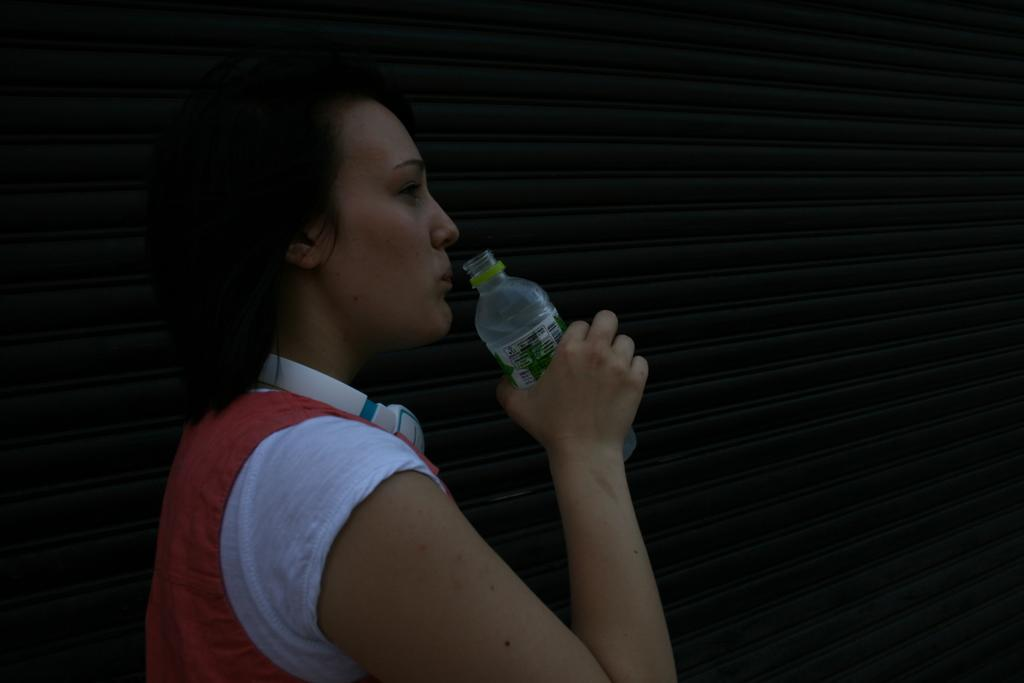What is the main subject of the image? The main subject of the image is a woman. What is the woman holding in her hand? The woman is holding a water bottle in her hand. Is the woman crying in the image? There is no indication in the image that the woman is crying. What part of the woman's brain can be seen in the image? There is no part of the woman's brain visible in the image. 